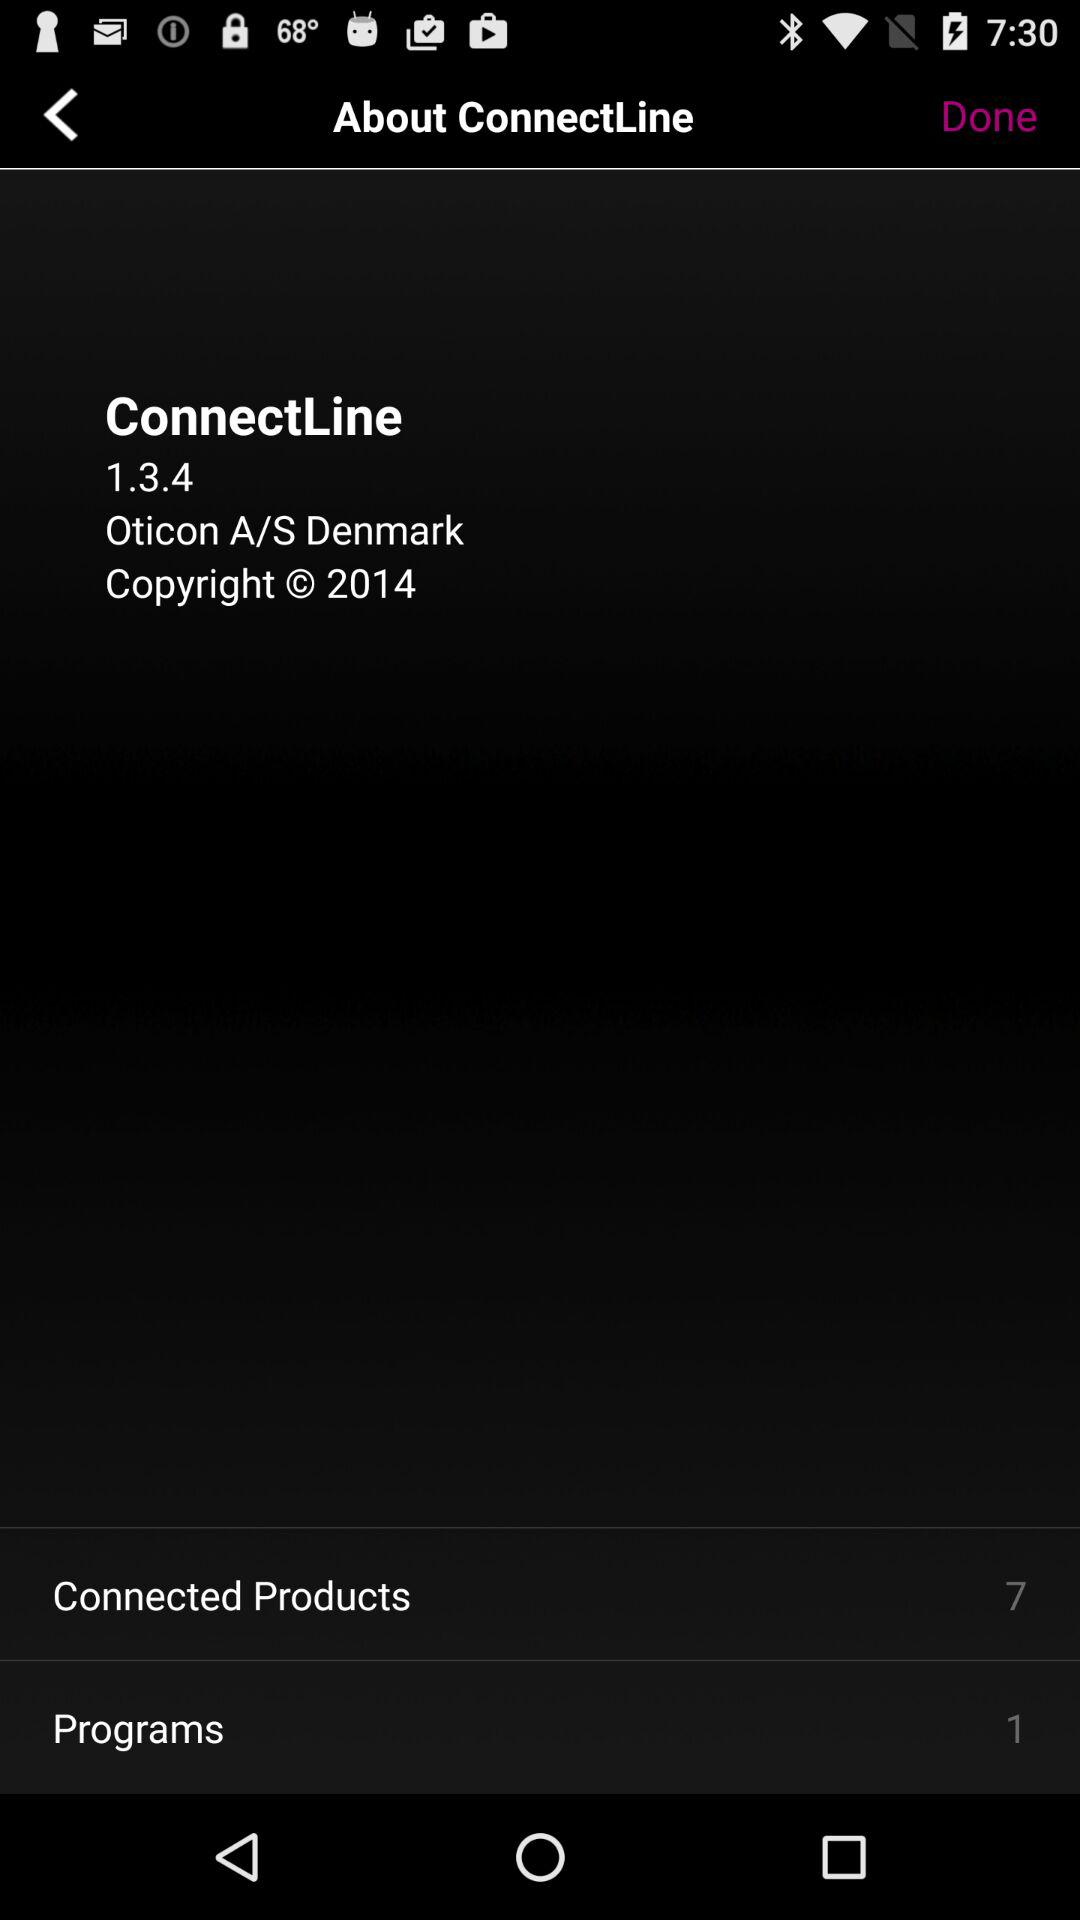What is the name of the user?
When the provided information is insufficient, respond with <no answer>. <no answer> 